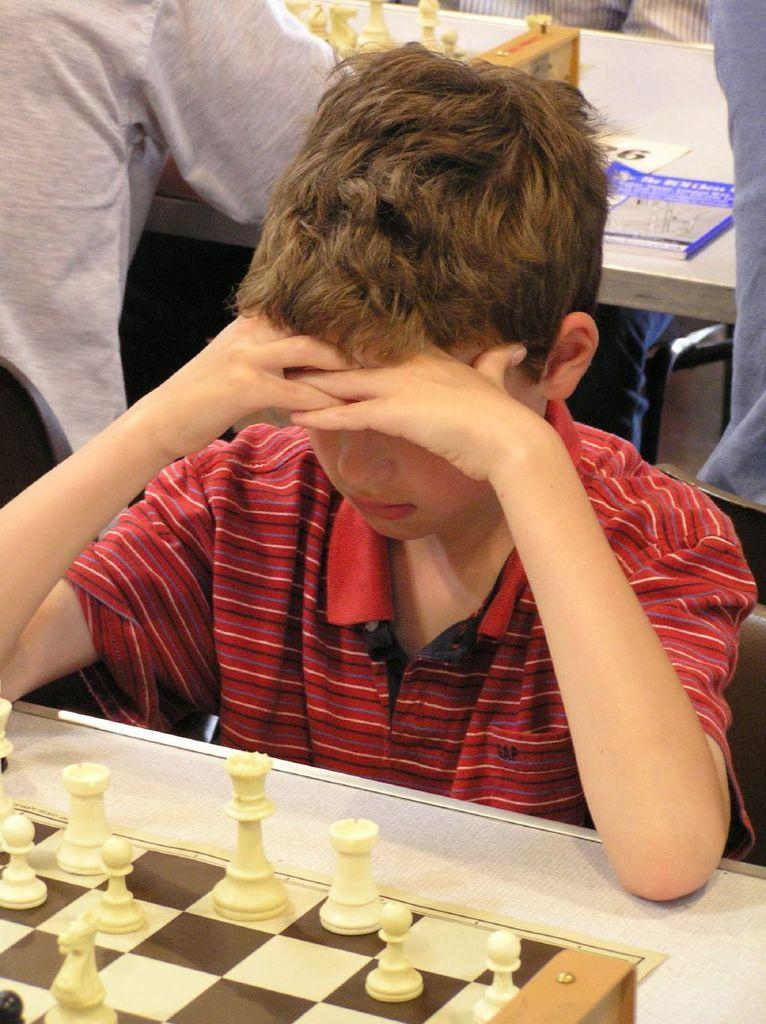What is the main subject of the image? There is a person sitting in front of a chess board. Can you describe the setting of the image? There is a group of people sitting in the background. What else can be seen in the image? There are books on a table in the image. What type of pet can be seen playing with a rose in the image? There is no pet or rose present in the image. 